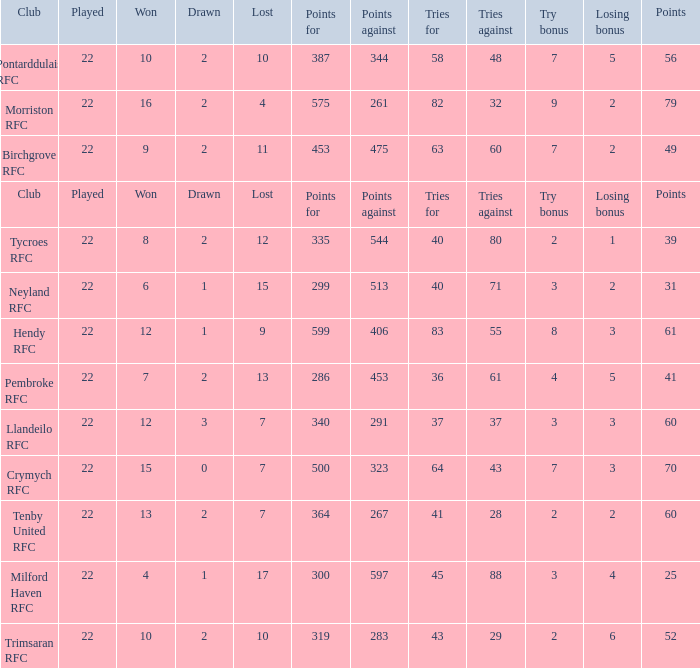 how many points against with tries for being 43 1.0. 